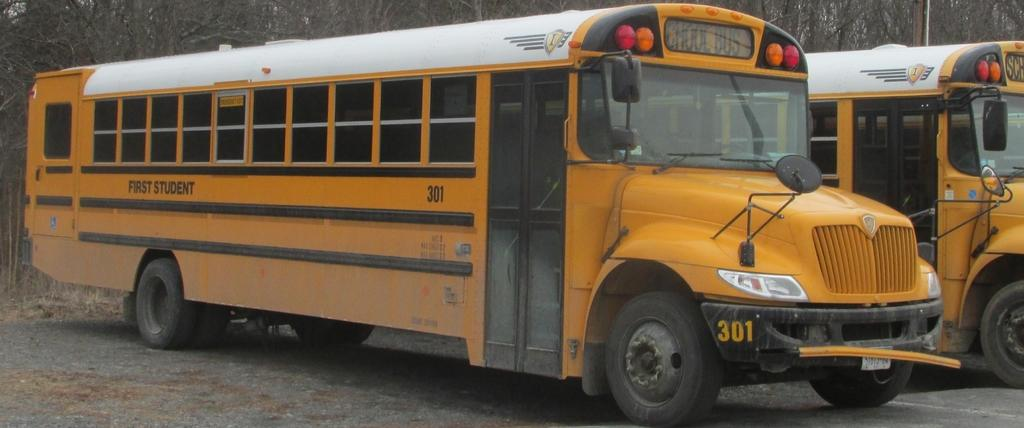What can be seen on the road in the image? There are vehicles on the road in the image. What type of natural scenery is visible in the background of the image? There are trees visible in the background of the image. What object can be seen in the image besides the vehicles and trees? There is a pole in the image. What type of wrist support is visible in the image? There is no wrist support present in the image. What activity is the person in the image paying attention to? There is no person visible in the image, so it is impossible to determine what they might be paying attention to. 